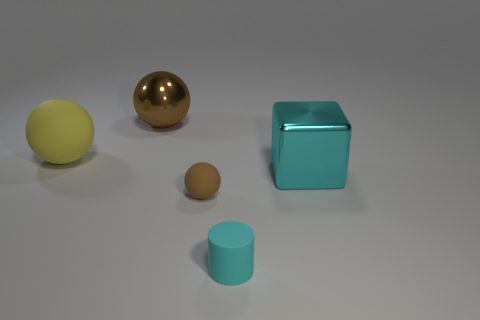Is the number of tiny green rubber cylinders greater than the number of tiny matte things?
Offer a very short reply. No. There is a big rubber ball; is its color the same as the object in front of the small matte sphere?
Offer a terse response. No. The rubber thing that is both to the right of the large brown sphere and to the left of the matte cylinder is what color?
Keep it short and to the point. Brown. How many other things are the same material as the cyan cube?
Make the answer very short. 1. Is the number of big red cylinders less than the number of big matte things?
Ensure brevity in your answer.  Yes. Does the tiny brown ball have the same material as the big object right of the tiny cyan cylinder?
Your answer should be very brief. No. What shape is the rubber thing that is on the left side of the big brown metal ball?
Your response must be concise. Sphere. Are there any other things of the same color as the shiny ball?
Ensure brevity in your answer.  Yes. Is the number of yellow balls that are in front of the block less than the number of purple metallic balls?
Give a very brief answer. No. What number of gray matte objects are the same size as the yellow ball?
Make the answer very short. 0. 